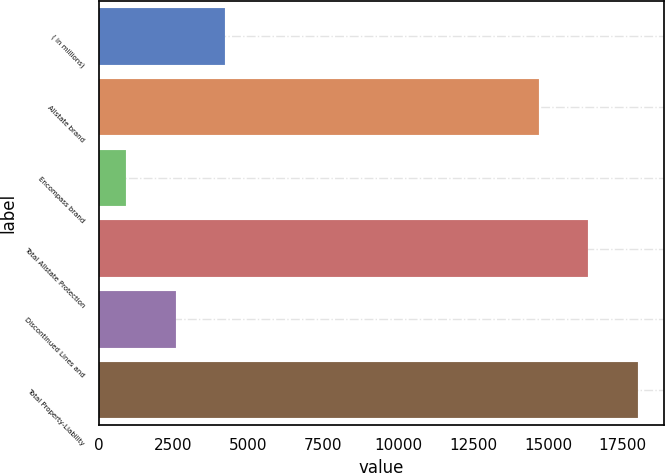Convert chart to OTSL. <chart><loc_0><loc_0><loc_500><loc_500><bar_chart><fcel>( in millions)<fcel>Allstate brand<fcel>Encompass brand<fcel>Total Allstate Protection<fcel>Discontinued Lines and<fcel>Total Property-Liability<nl><fcel>4216<fcel>14696<fcel>921<fcel>16343.5<fcel>2568.5<fcel>17991<nl></chart> 